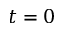Convert formula to latex. <formula><loc_0><loc_0><loc_500><loc_500>t = 0</formula> 